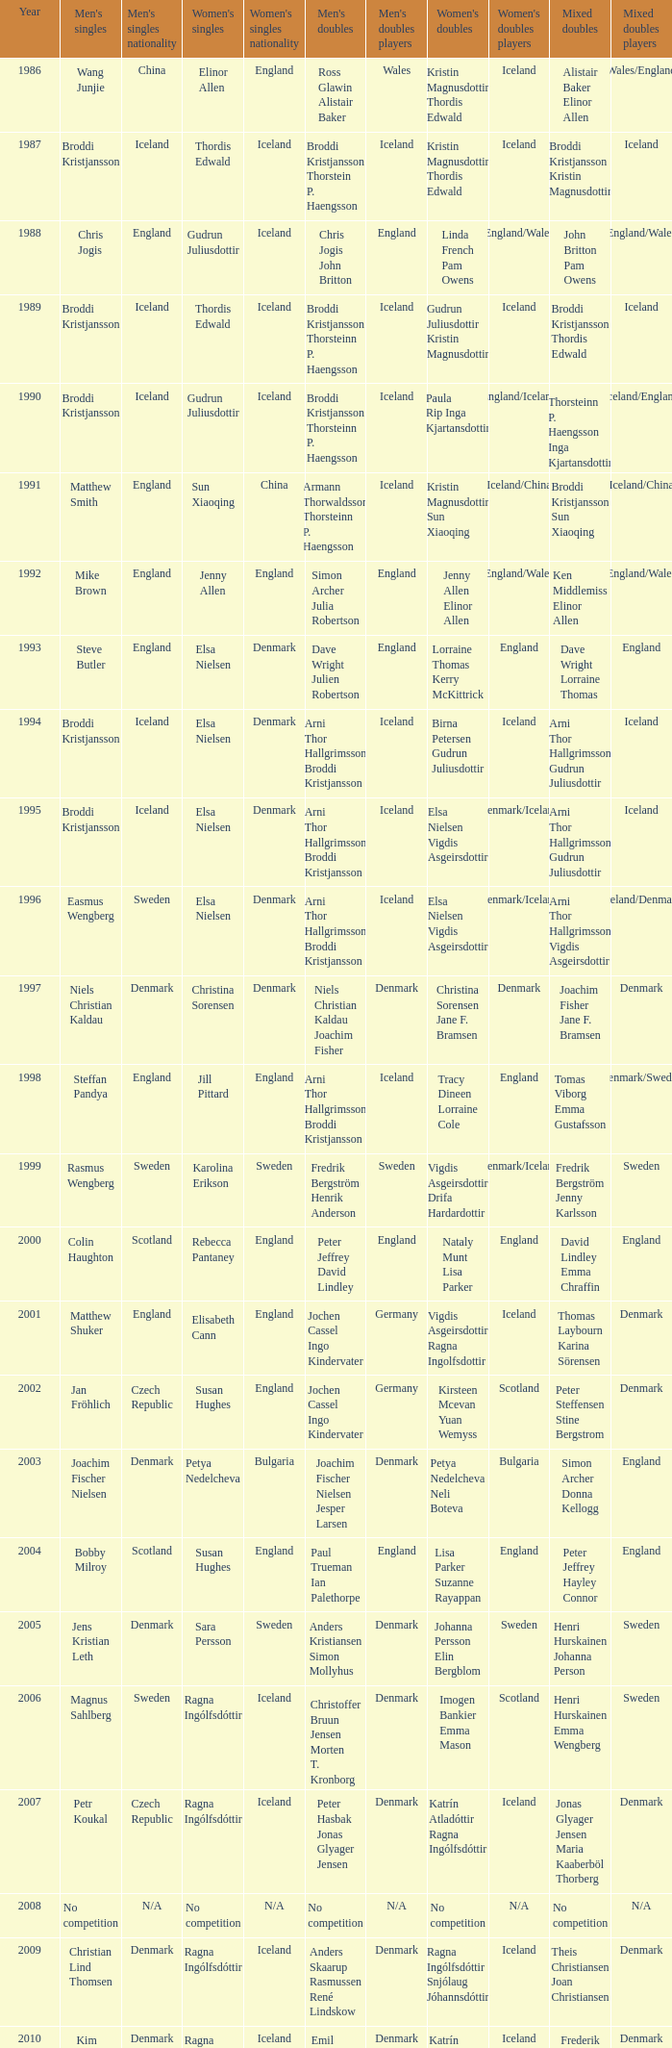In which women's doubles did Wang Junjie play men's singles? Kristin Magnusdottir Thordis Edwald. 